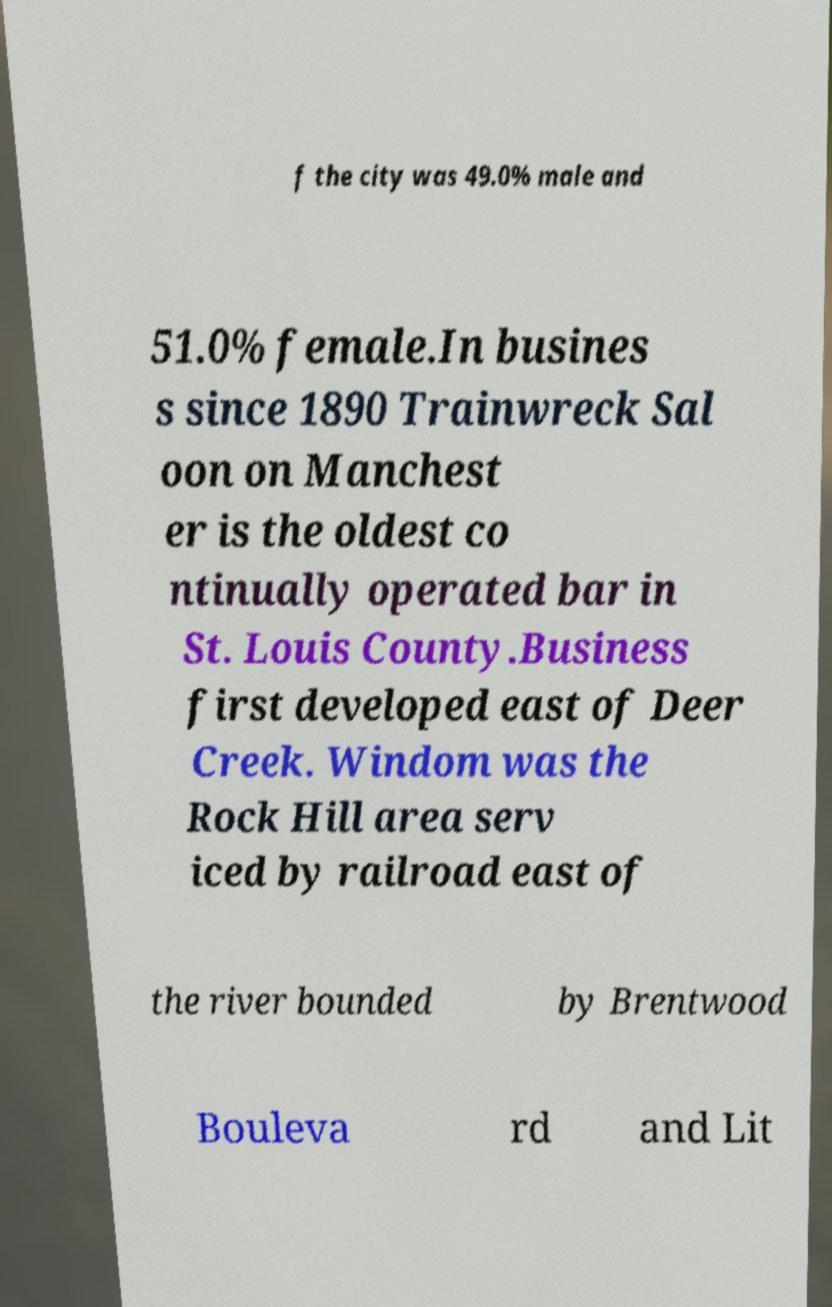I need the written content from this picture converted into text. Can you do that? f the city was 49.0% male and 51.0% female.In busines s since 1890 Trainwreck Sal oon on Manchest er is the oldest co ntinually operated bar in St. Louis County.Business first developed east of Deer Creek. Windom was the Rock Hill area serv iced by railroad east of the river bounded by Brentwood Bouleva rd and Lit 